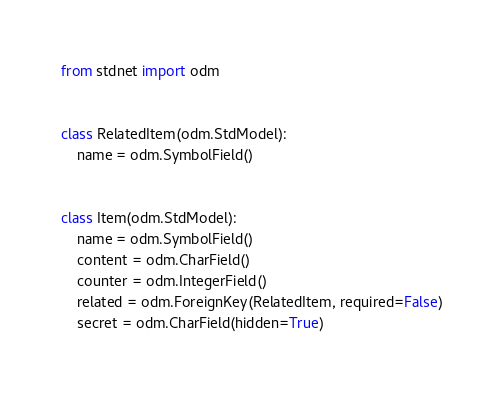Convert code to text. <code><loc_0><loc_0><loc_500><loc_500><_Python_>from stdnet import odm


class RelatedItem(odm.StdModel):
    name = odm.SymbolField()


class Item(odm.StdModel):
    name = odm.SymbolField()
    content = odm.CharField()
    counter = odm.IntegerField()
    related = odm.ForeignKey(RelatedItem, required=False)
    secret = odm.CharField(hidden=True)
</code> 